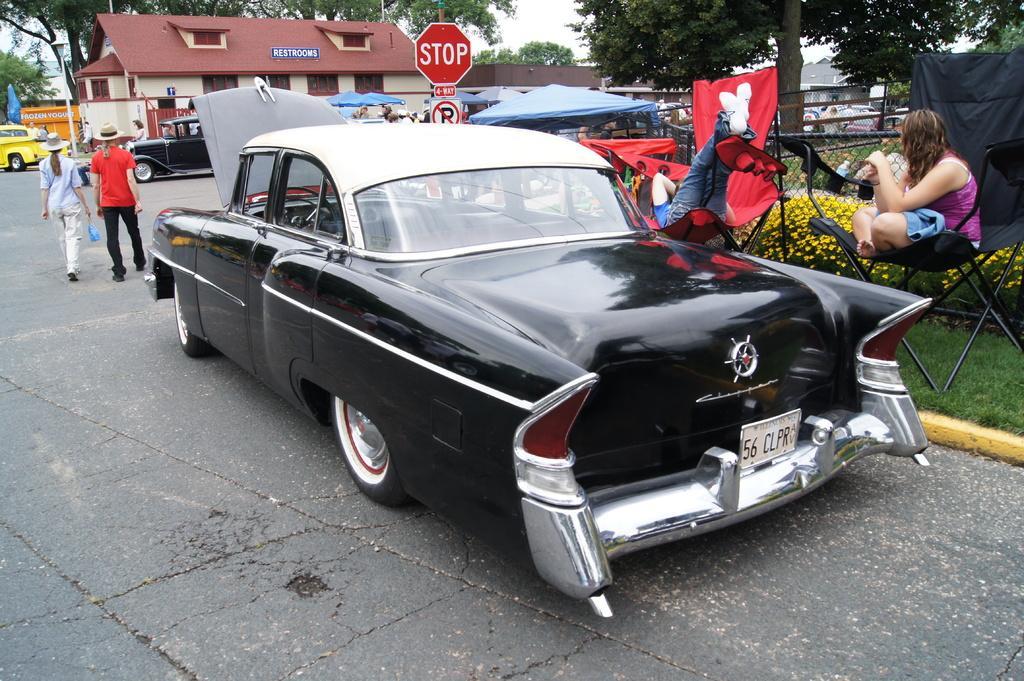Could you give a brief overview of what you see in this image? In this image in the front there is a car which is black in colour. On the right side there is grass on the ground and there is a person sitting and there are plants and there is a black tent and there are red colour objects. In the background there are buildings, trees, cars and there are persons. In the center there is a board with some text written on it and there are blue colour tents. 